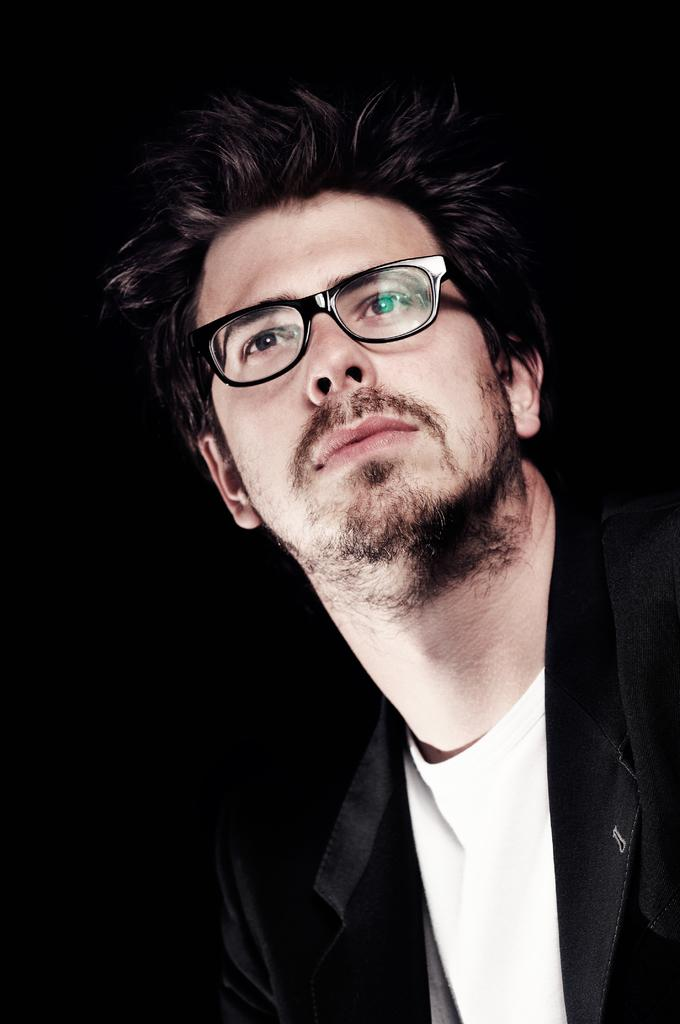What is the main subject of the image? The main subject of the image is a man. What color is the jacket the man is wearing? The man is wearing a black color jacket. What type of shirt is the man wearing under his jacket? The man is wearing a white t-shirt. What accessory is the man wearing on his face? The man is wearing spectacles. How would you describe the lighting or color of the background in the image? The background of the image is dark. How many spiders can be seen crawling on the curve in the image? There are no spiders or curves present in the image; it features a man wearing a black jacket, white t-shirt, and spectacles against a dark background. 